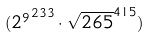Convert formula to latex. <formula><loc_0><loc_0><loc_500><loc_500>( { 2 ^ { 9 } } ^ { 2 3 3 } \cdot \sqrt { 2 6 5 } ^ { 4 1 5 } )</formula> 